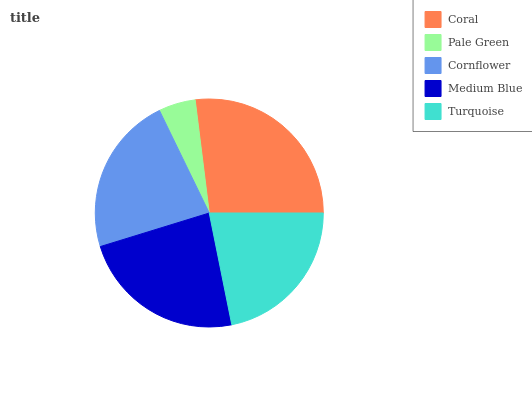Is Pale Green the minimum?
Answer yes or no. Yes. Is Coral the maximum?
Answer yes or no. Yes. Is Cornflower the minimum?
Answer yes or no. No. Is Cornflower the maximum?
Answer yes or no. No. Is Cornflower greater than Pale Green?
Answer yes or no. Yes. Is Pale Green less than Cornflower?
Answer yes or no. Yes. Is Pale Green greater than Cornflower?
Answer yes or no. No. Is Cornflower less than Pale Green?
Answer yes or no. No. Is Cornflower the high median?
Answer yes or no. Yes. Is Cornflower the low median?
Answer yes or no. Yes. Is Pale Green the high median?
Answer yes or no. No. Is Turquoise the low median?
Answer yes or no. No. 